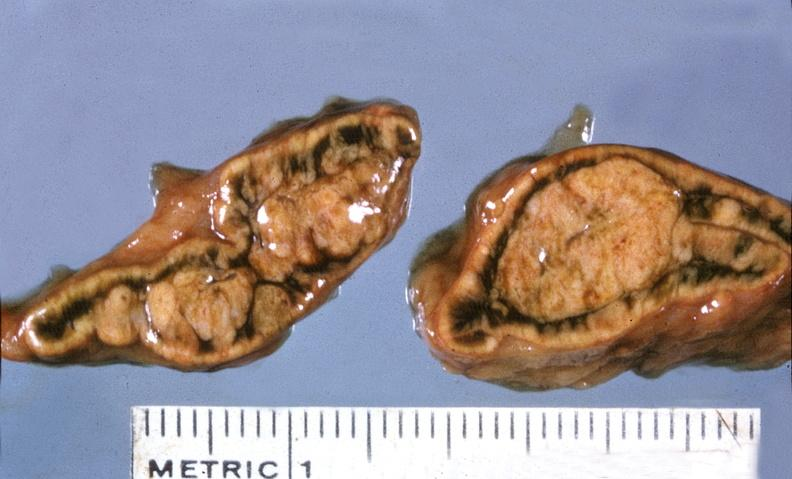where does this belong to?
Answer the question using a single word or phrase. Endocrine system 